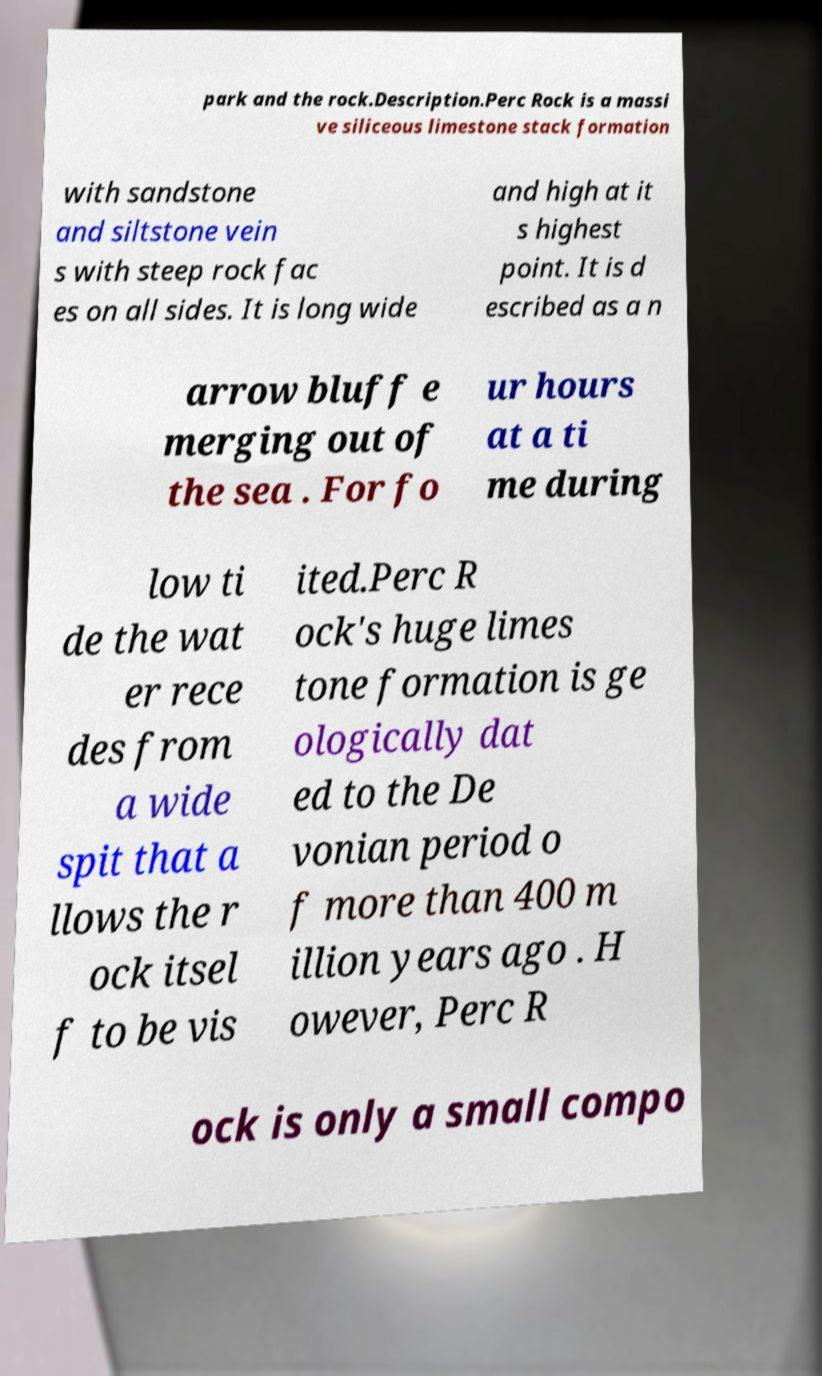I need the written content from this picture converted into text. Can you do that? park and the rock.Description.Perc Rock is a massi ve siliceous limestone stack formation with sandstone and siltstone vein s with steep rock fac es on all sides. It is long wide and high at it s highest point. It is d escribed as a n arrow bluff e merging out of the sea . For fo ur hours at a ti me during low ti de the wat er rece des from a wide spit that a llows the r ock itsel f to be vis ited.Perc R ock's huge limes tone formation is ge ologically dat ed to the De vonian period o f more than 400 m illion years ago . H owever, Perc R ock is only a small compo 